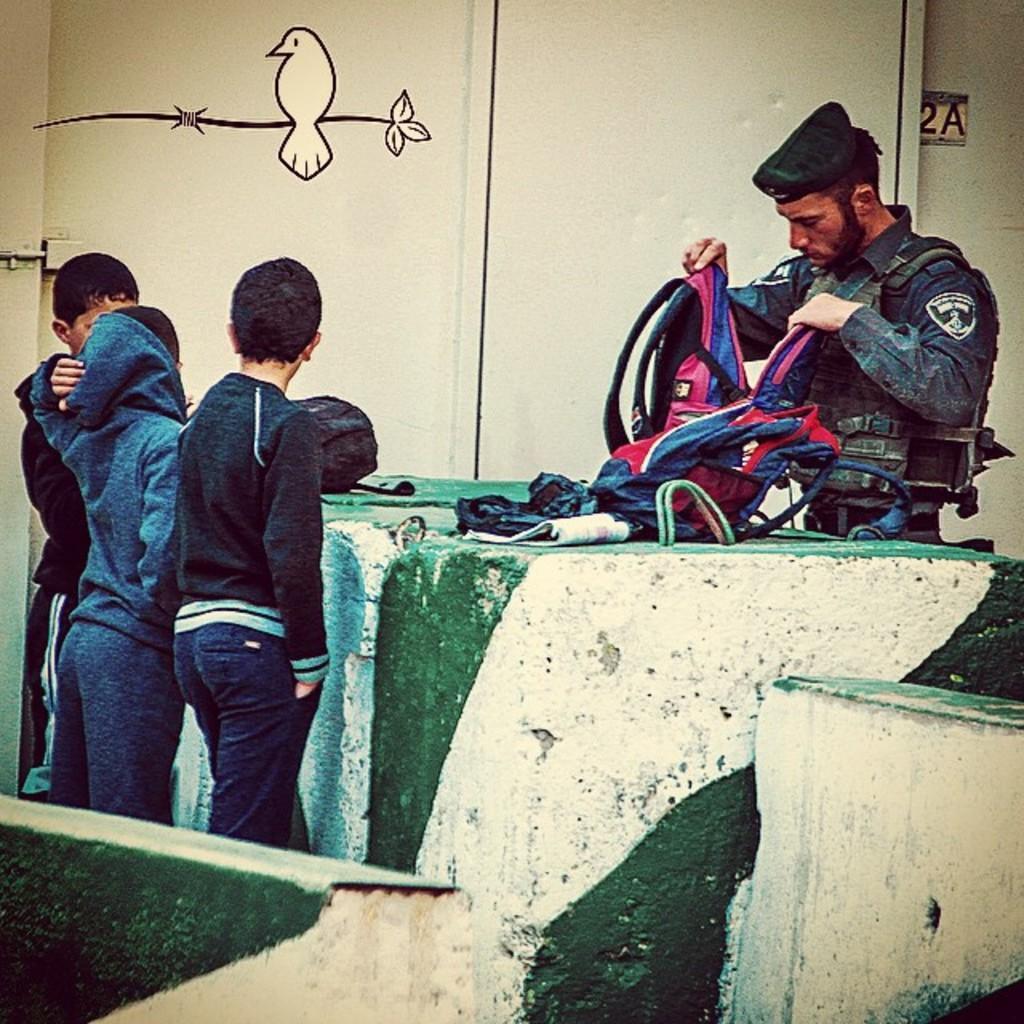Could you give a brief overview of what you see in this image? Here we can see four persons. He is holding a bag with his hands and there are clothes. In the background we can see a wall and there is a painting. 